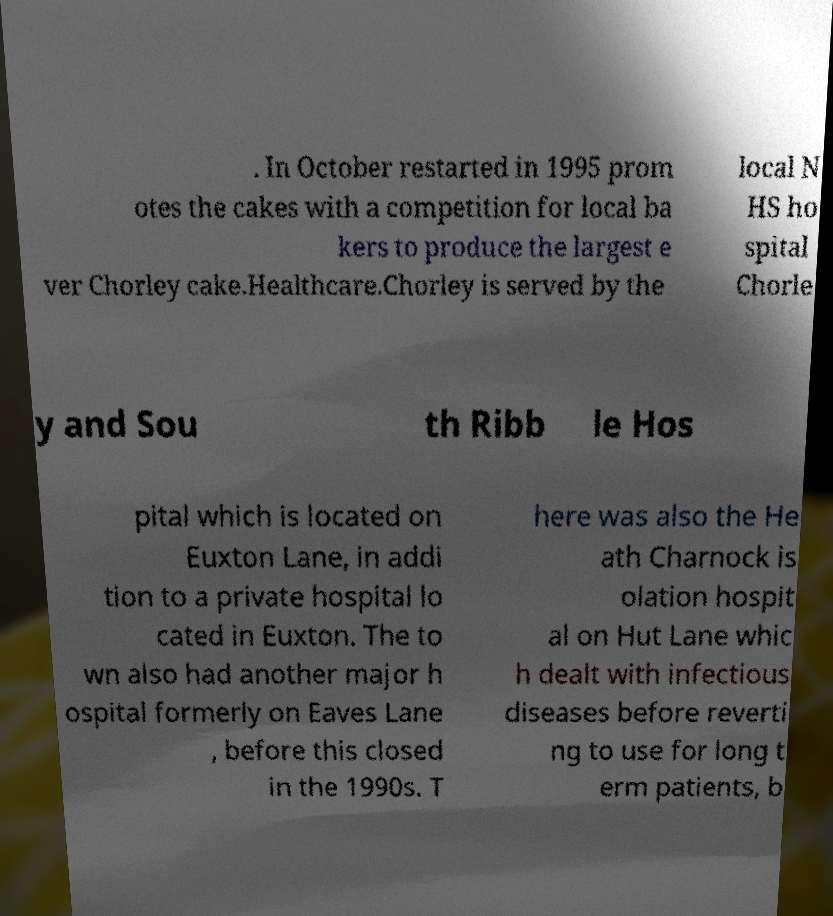Please read and relay the text visible in this image. What does it say? . In October restarted in 1995 prom otes the cakes with a competition for local ba kers to produce the largest e ver Chorley cake.Healthcare.Chorley is served by the local N HS ho spital Chorle y and Sou th Ribb le Hos pital which is located on Euxton Lane, in addi tion to a private hospital lo cated in Euxton. The to wn also had another major h ospital formerly on Eaves Lane , before this closed in the 1990s. T here was also the He ath Charnock is olation hospit al on Hut Lane whic h dealt with infectious diseases before reverti ng to use for long t erm patients, b 